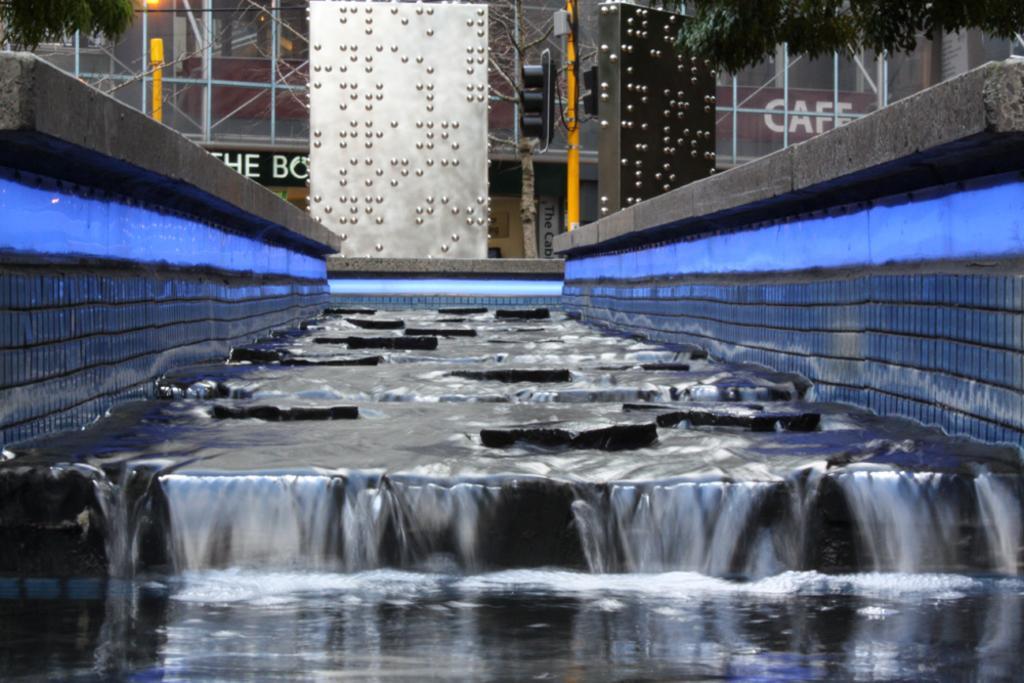Describe this image in one or two sentences. In the foreground of this image, there is a flat surface water fall on which we can see few stones. In the background, there is glass building, pole, few boards like objects and trees at the top. 